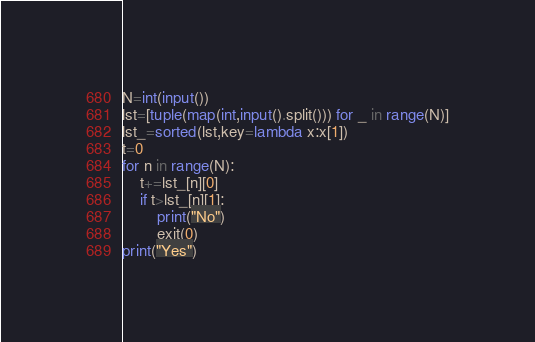Convert code to text. <code><loc_0><loc_0><loc_500><loc_500><_Python_>N=int(input())
lst=[tuple(map(int,input().split())) for _ in range(N)]
lst_=sorted(lst,key=lambda x:x[1])
t=0
for n in range(N):
    t+=lst_[n][0]
    if t>lst_[n][1]:
        print("No")
        exit(0)
print("Yes")</code> 